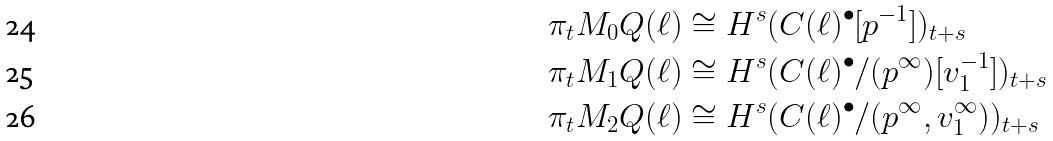Convert formula to latex. <formula><loc_0><loc_0><loc_500><loc_500>\pi _ { t } M _ { 0 } Q ( \ell ) & \cong H ^ { s } ( C ( \ell ) ^ { \bullet } [ p ^ { - 1 } ] ) _ { t + s } \\ \pi _ { t } M _ { 1 } Q ( \ell ) & \cong H ^ { s } ( C ( \ell ) ^ { \bullet } / ( p ^ { \infty } ) [ v _ { 1 } ^ { - 1 } ] ) _ { t + s } \\ \pi _ { t } M _ { 2 } Q ( \ell ) & \cong H ^ { s } ( C ( \ell ) ^ { \bullet } / ( p ^ { \infty } , v _ { 1 } ^ { \infty } ) ) _ { t + s }</formula> 